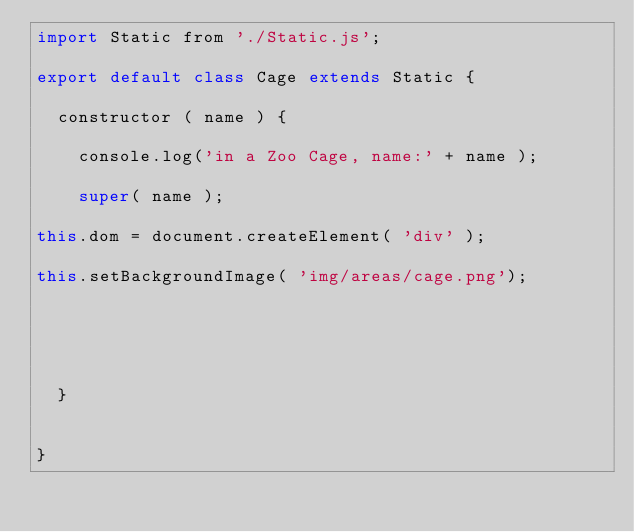Convert code to text. <code><loc_0><loc_0><loc_500><loc_500><_JavaScript_>import Static from './Static.js';

export default class Cage extends Static {
	
	constructor ( name ) {

		console.log('in a Zoo Cage, name:' + name );

		super( name );

this.dom = document.createElement( 'div' );

this.setBackgroundImage( 'img/areas/cage.png');

	



	}


}</code> 